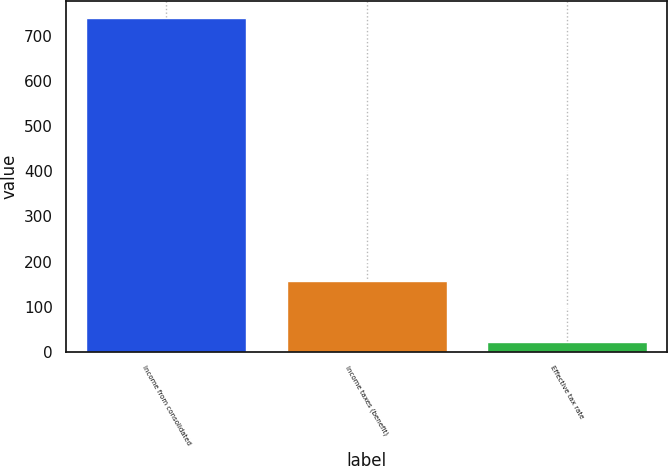Convert chart to OTSL. <chart><loc_0><loc_0><loc_500><loc_500><bar_chart><fcel>Income from consolidated<fcel>Income taxes (benefit)<fcel>Effective tax rate<nl><fcel>741.3<fcel>157.3<fcel>21.2<nl></chart> 